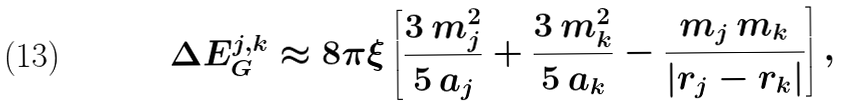Convert formula to latex. <formula><loc_0><loc_0><loc_500><loc_500>\Delta E ^ { j , k } _ { G } \approx 8 \pi \xi \left [ \frac { 3 \, m _ { j } ^ { 2 } } { 5 \, a _ { j } } + \frac { 3 \, m _ { k } ^ { 2 } } { 5 \, a _ { k } } - \frac { m _ { j } \, m _ { k } } { | { r } _ { j } - { r } _ { k } | } \right ] ,</formula> 